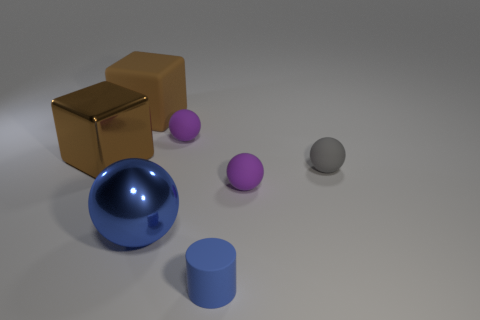What is the color of the metal thing that is the same shape as the gray rubber thing?
Offer a very short reply. Blue. Does the shiny cube have the same size as the rubber block?
Offer a very short reply. Yes. There is a big brown cube right of the large brown metal thing; what material is it?
Ensure brevity in your answer.  Rubber. What number of other objects are there of the same shape as the large blue metal object?
Your answer should be very brief. 3. Does the gray thing have the same shape as the blue metallic thing?
Keep it short and to the point. Yes. There is a gray rubber sphere; are there any big brown metal objects behind it?
Your answer should be compact. Yes. How many things are red metallic cubes or cylinders?
Your response must be concise. 1. What number of other things are the same size as the rubber cylinder?
Offer a very short reply. 3. How many things are behind the large sphere and in front of the big brown shiny cube?
Make the answer very short. 2. There is a purple matte ball in front of the gray rubber object; does it have the same size as the shiny thing that is behind the large shiny sphere?
Your response must be concise. No. 